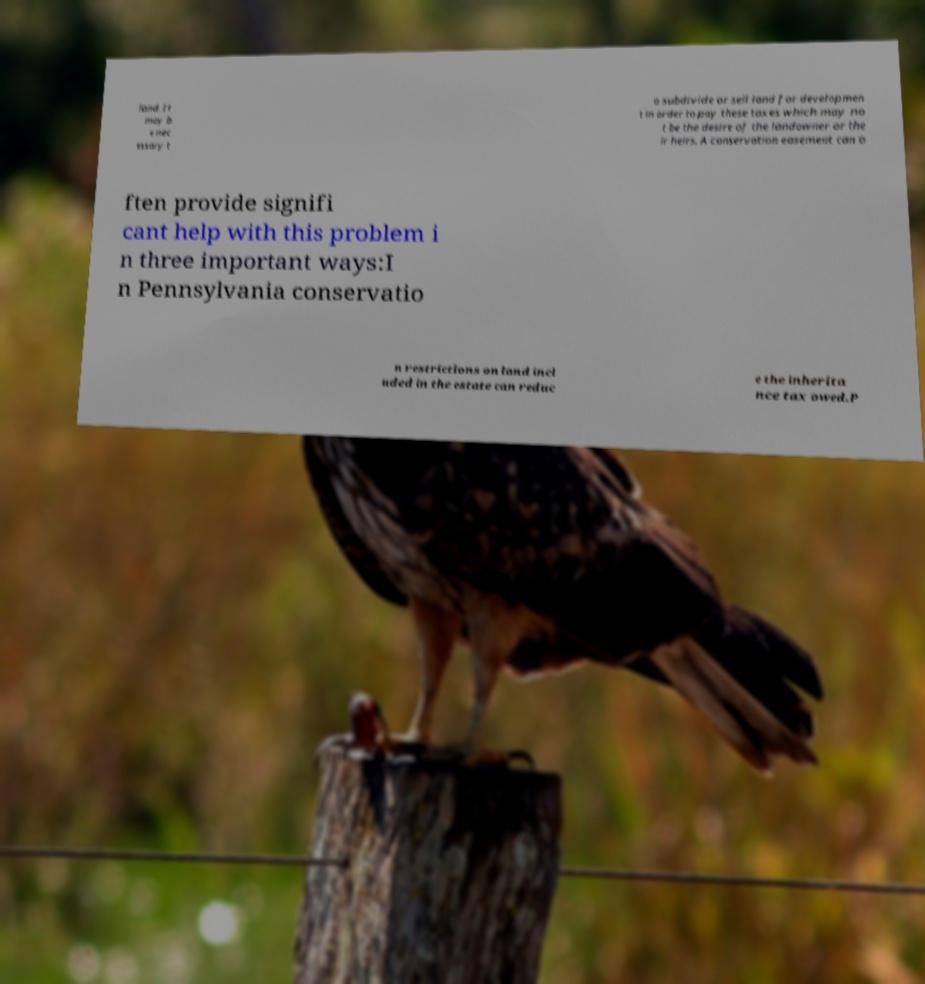Please identify and transcribe the text found in this image. land. It may b e nec essary t o subdivide or sell land for developmen t in order to pay these taxes which may no t be the desire of the landowner or the ir heirs. A conservation easement can o ften provide signifi cant help with this problem i n three important ways:I n Pennsylvania conservatio n restrictions on land incl uded in the estate can reduc e the inherita nce tax owed.P 